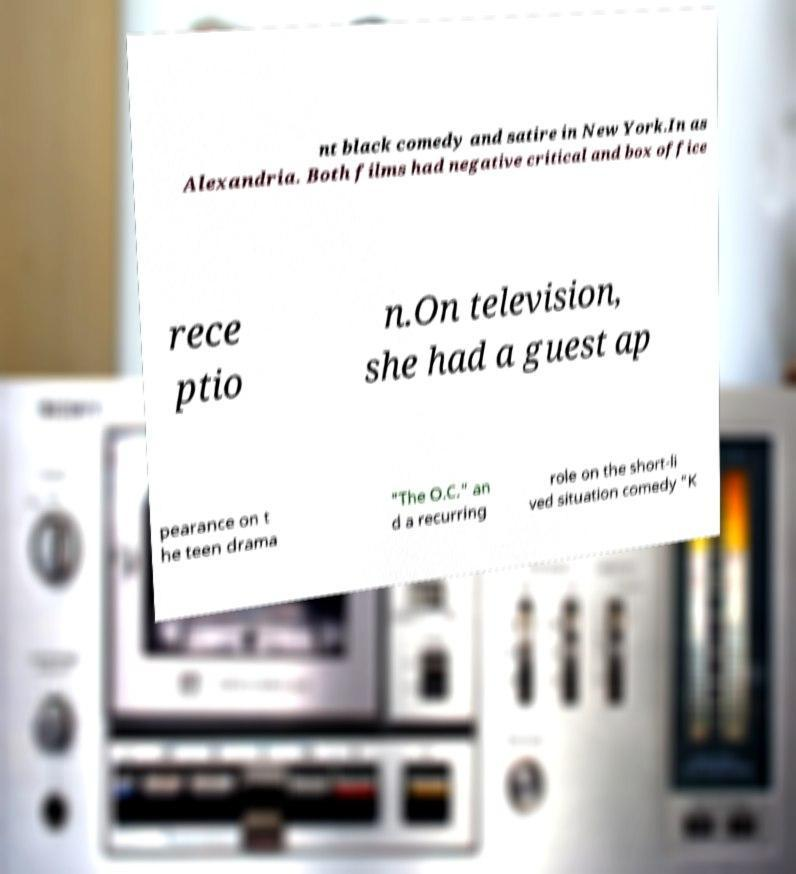What messages or text are displayed in this image? I need them in a readable, typed format. nt black comedy and satire in New York.In as Alexandria. Both films had negative critical and box office rece ptio n.On television, she had a guest ap pearance on t he teen drama "The O.C." an d a recurring role on the short-li ved situation comedy "K 